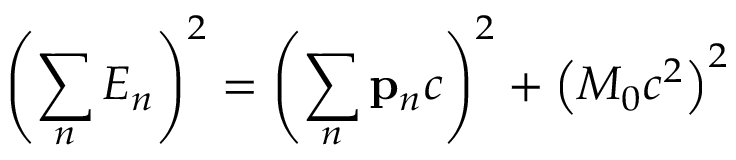Convert formula to latex. <formula><loc_0><loc_0><loc_500><loc_500>\left ( \sum _ { n } E _ { n } \right ) ^ { 2 } = \left ( \sum _ { n } p _ { n } c \right ) ^ { 2 } + \left ( M _ { 0 } c ^ { 2 } \right ) ^ { 2 }</formula> 